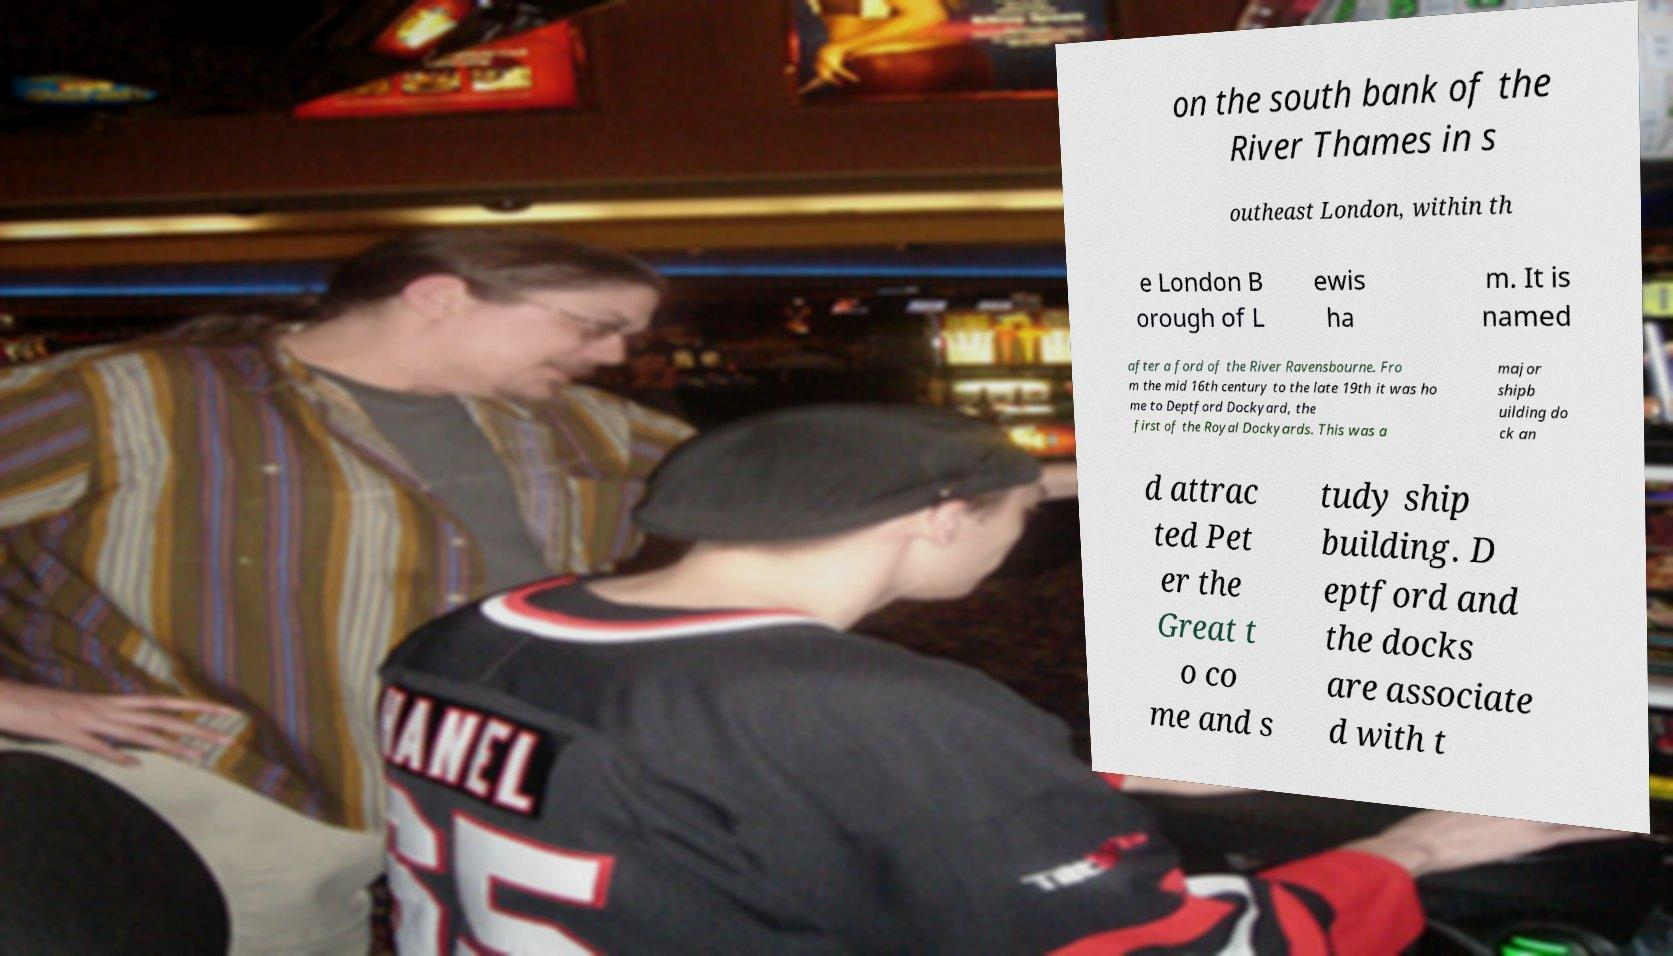What messages or text are displayed in this image? I need them in a readable, typed format. on the south bank of the River Thames in s outheast London, within th e London B orough of L ewis ha m. It is named after a ford of the River Ravensbourne. Fro m the mid 16th century to the late 19th it was ho me to Deptford Dockyard, the first of the Royal Dockyards. This was a major shipb uilding do ck an d attrac ted Pet er the Great t o co me and s tudy ship building. D eptford and the docks are associate d with t 